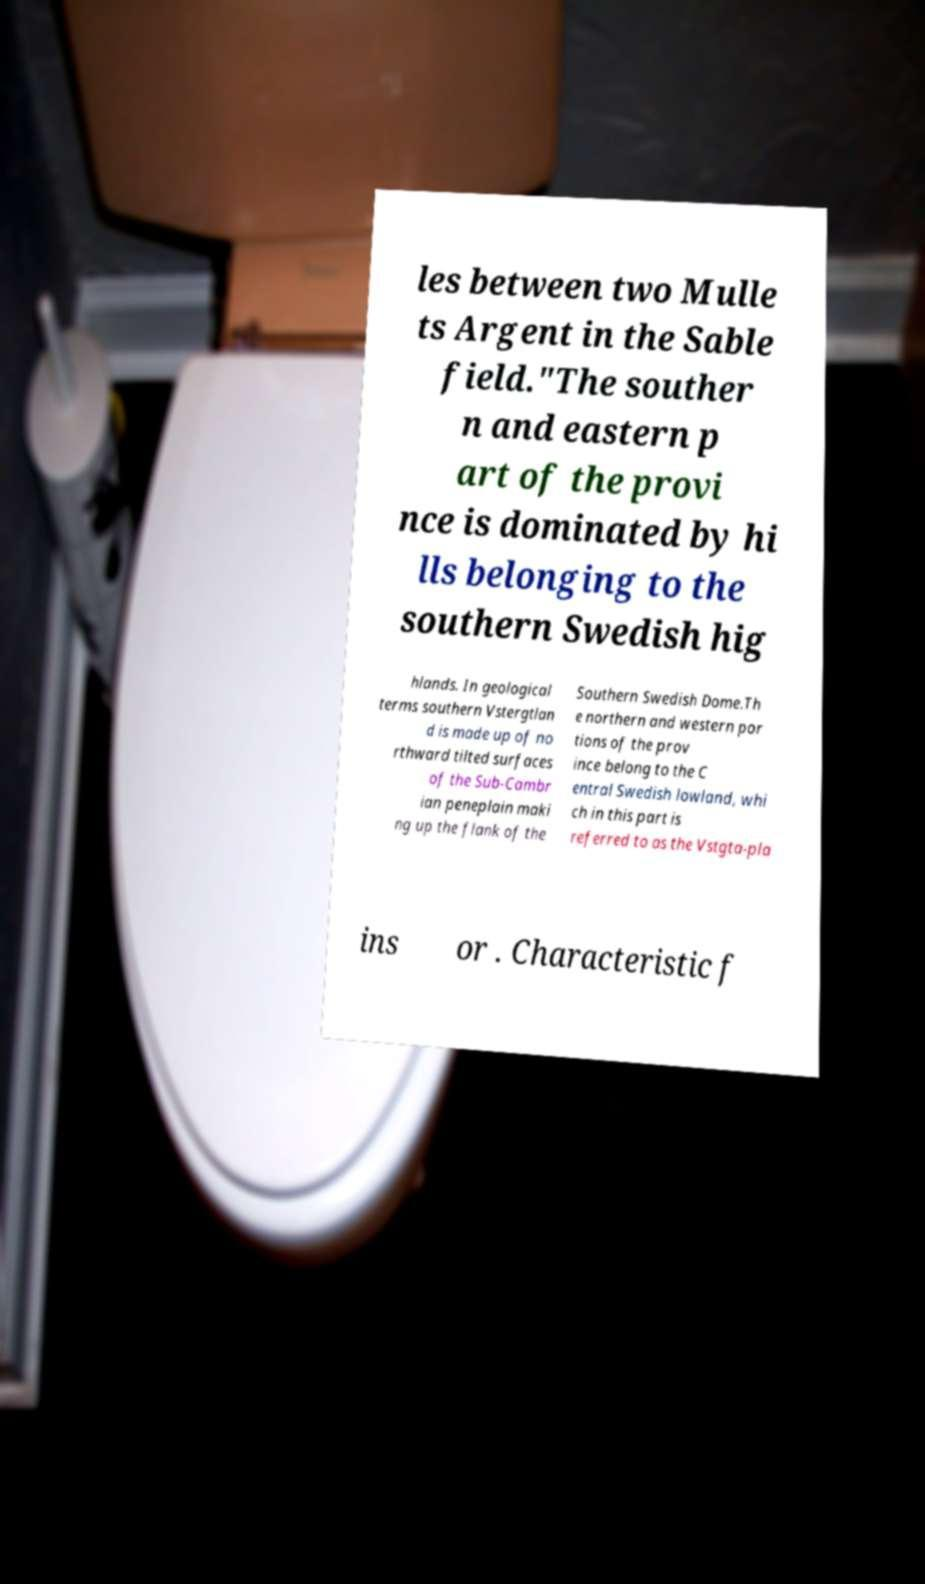What messages or text are displayed in this image? I need them in a readable, typed format. les between two Mulle ts Argent in the Sable field."The souther n and eastern p art of the provi nce is dominated by hi lls belonging to the southern Swedish hig hlands. In geological terms southern Vstergtlan d is made up of no rthward tilted surfaces of the Sub-Cambr ian peneplain maki ng up the flank of the Southern Swedish Dome.Th e northern and western por tions of the prov ince belong to the C entral Swedish lowland, whi ch in this part is referred to as the Vstgta-pla ins or . Characteristic f 